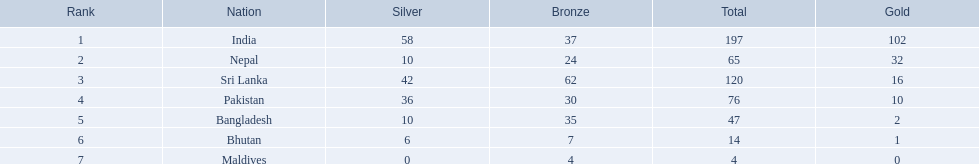What are the nations? India, Nepal, Sri Lanka, Pakistan, Bangladesh, Bhutan, Maldives. Of these, which one has earned the least amount of gold medals? Maldives. 